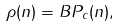Convert formula to latex. <formula><loc_0><loc_0><loc_500><loc_500>\rho ( n ) = B P _ { c } ( n ) ,</formula> 